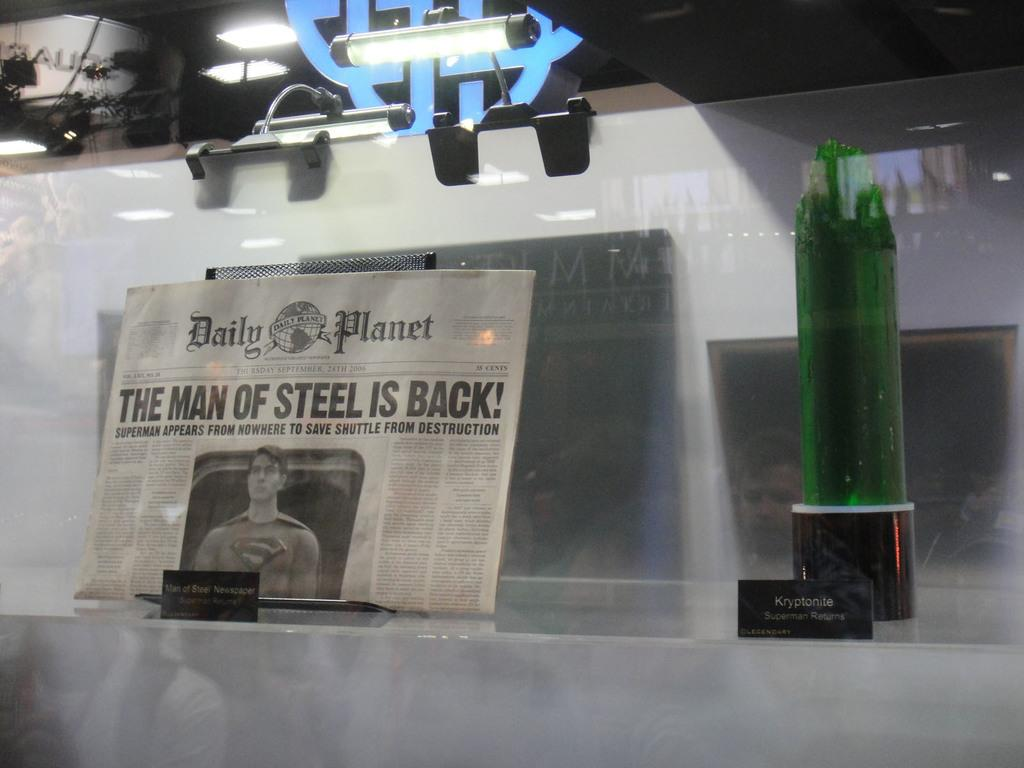<image>
Describe the image concisely. Newspaper behind some glass with the article "The Man of Steel Is Back". 